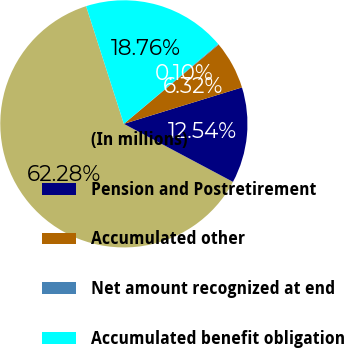Convert chart to OTSL. <chart><loc_0><loc_0><loc_500><loc_500><pie_chart><fcel>(In millions)<fcel>Pension and Postretirement<fcel>Accumulated other<fcel>Net amount recognized at end<fcel>Accumulated benefit obligation<nl><fcel>62.29%<fcel>12.54%<fcel>6.32%<fcel>0.1%<fcel>18.76%<nl></chart> 